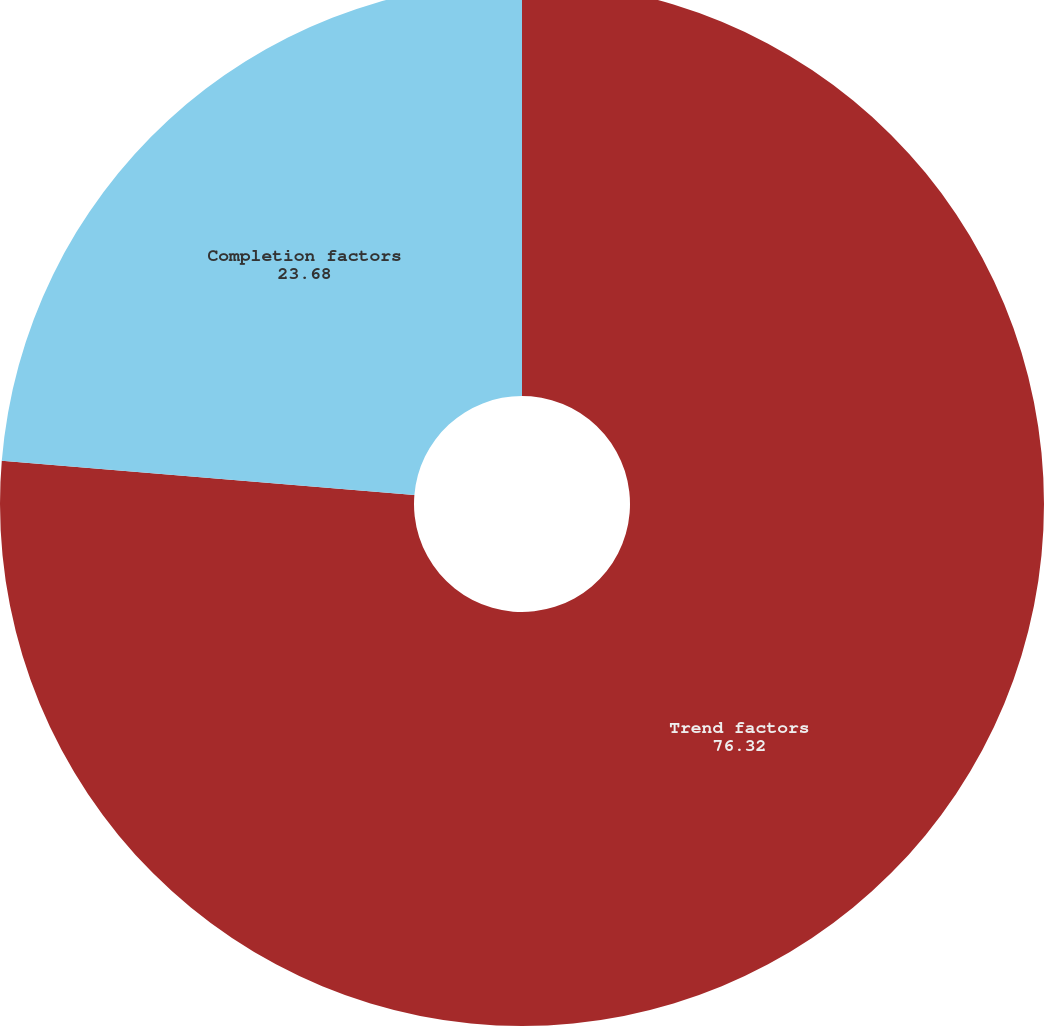Convert chart. <chart><loc_0><loc_0><loc_500><loc_500><pie_chart><fcel>Trend factors<fcel>Completion factors<nl><fcel>76.32%<fcel>23.68%<nl></chart> 